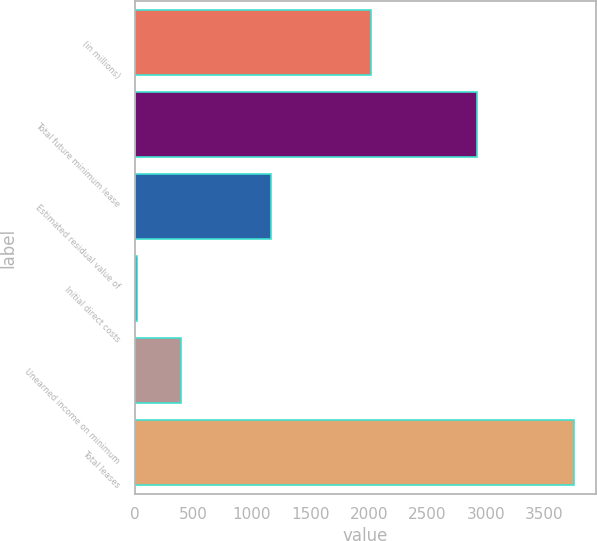Convert chart to OTSL. <chart><loc_0><loc_0><loc_500><loc_500><bar_chart><fcel>(in millions)<fcel>Total future minimum lease<fcel>Estimated residual value of<fcel>Initial direct costs<fcel>Unearned income on minimum<fcel>Total leases<nl><fcel>2016<fcel>2922<fcel>1166<fcel>20<fcel>393.3<fcel>3753<nl></chart> 